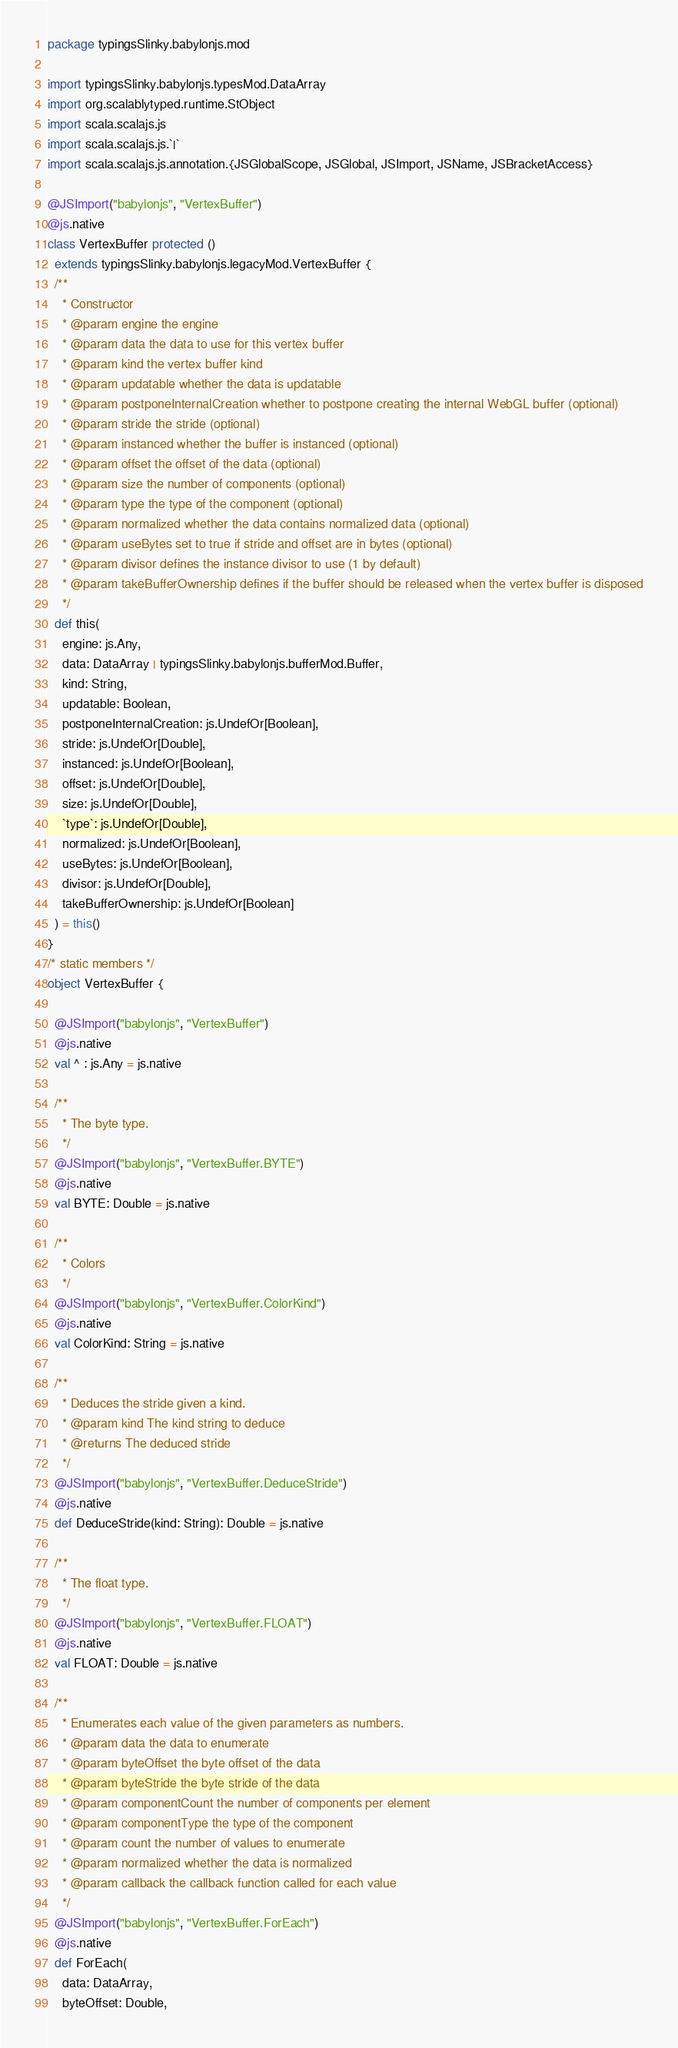<code> <loc_0><loc_0><loc_500><loc_500><_Scala_>package typingsSlinky.babylonjs.mod

import typingsSlinky.babylonjs.typesMod.DataArray
import org.scalablytyped.runtime.StObject
import scala.scalajs.js
import scala.scalajs.js.`|`
import scala.scalajs.js.annotation.{JSGlobalScope, JSGlobal, JSImport, JSName, JSBracketAccess}

@JSImport("babylonjs", "VertexBuffer")
@js.native
class VertexBuffer protected ()
  extends typingsSlinky.babylonjs.legacyMod.VertexBuffer {
  /**
    * Constructor
    * @param engine the engine
    * @param data the data to use for this vertex buffer
    * @param kind the vertex buffer kind
    * @param updatable whether the data is updatable
    * @param postponeInternalCreation whether to postpone creating the internal WebGL buffer (optional)
    * @param stride the stride (optional)
    * @param instanced whether the buffer is instanced (optional)
    * @param offset the offset of the data (optional)
    * @param size the number of components (optional)
    * @param type the type of the component (optional)
    * @param normalized whether the data contains normalized data (optional)
    * @param useBytes set to true if stride and offset are in bytes (optional)
    * @param divisor defines the instance divisor to use (1 by default)
    * @param takeBufferOwnership defines if the buffer should be released when the vertex buffer is disposed
    */
  def this(
    engine: js.Any,
    data: DataArray | typingsSlinky.babylonjs.bufferMod.Buffer,
    kind: String,
    updatable: Boolean,
    postponeInternalCreation: js.UndefOr[Boolean],
    stride: js.UndefOr[Double],
    instanced: js.UndefOr[Boolean],
    offset: js.UndefOr[Double],
    size: js.UndefOr[Double],
    `type`: js.UndefOr[Double],
    normalized: js.UndefOr[Boolean],
    useBytes: js.UndefOr[Boolean],
    divisor: js.UndefOr[Double],
    takeBufferOwnership: js.UndefOr[Boolean]
  ) = this()
}
/* static members */
object VertexBuffer {
  
  @JSImport("babylonjs", "VertexBuffer")
  @js.native
  val ^ : js.Any = js.native
  
  /**
    * The byte type.
    */
  @JSImport("babylonjs", "VertexBuffer.BYTE")
  @js.native
  val BYTE: Double = js.native
  
  /**
    * Colors
    */
  @JSImport("babylonjs", "VertexBuffer.ColorKind")
  @js.native
  val ColorKind: String = js.native
  
  /**
    * Deduces the stride given a kind.
    * @param kind The kind string to deduce
    * @returns The deduced stride
    */
  @JSImport("babylonjs", "VertexBuffer.DeduceStride")
  @js.native
  def DeduceStride(kind: String): Double = js.native
  
  /**
    * The float type.
    */
  @JSImport("babylonjs", "VertexBuffer.FLOAT")
  @js.native
  val FLOAT: Double = js.native
  
  /**
    * Enumerates each value of the given parameters as numbers.
    * @param data the data to enumerate
    * @param byteOffset the byte offset of the data
    * @param byteStride the byte stride of the data
    * @param componentCount the number of components per element
    * @param componentType the type of the component
    * @param count the number of values to enumerate
    * @param normalized whether the data is normalized
    * @param callback the callback function called for each value
    */
  @JSImport("babylonjs", "VertexBuffer.ForEach")
  @js.native
  def ForEach(
    data: DataArray,
    byteOffset: Double,</code> 